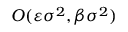Convert formula to latex. <formula><loc_0><loc_0><loc_500><loc_500>O ( \varepsilon \sigma ^ { 2 } , \beta \sigma ^ { 2 } )</formula> 